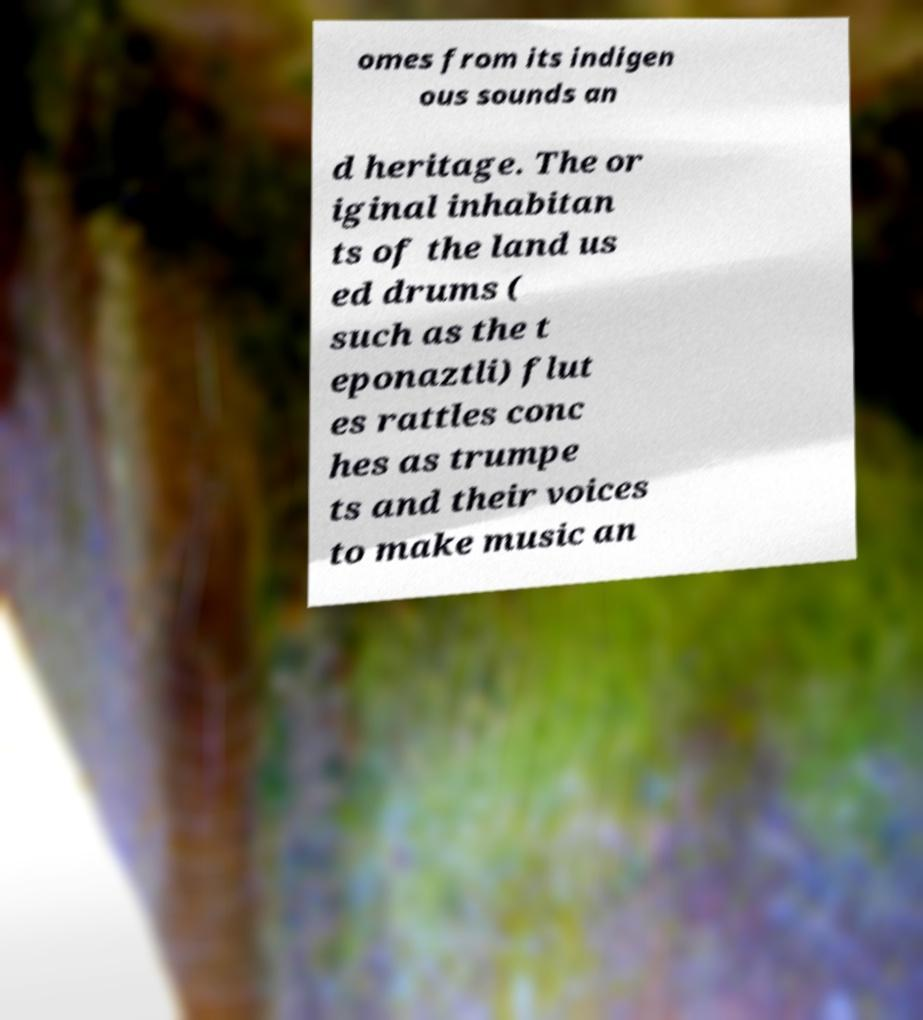Could you extract and type out the text from this image? omes from its indigen ous sounds an d heritage. The or iginal inhabitan ts of the land us ed drums ( such as the t eponaztli) flut es rattles conc hes as trumpe ts and their voices to make music an 